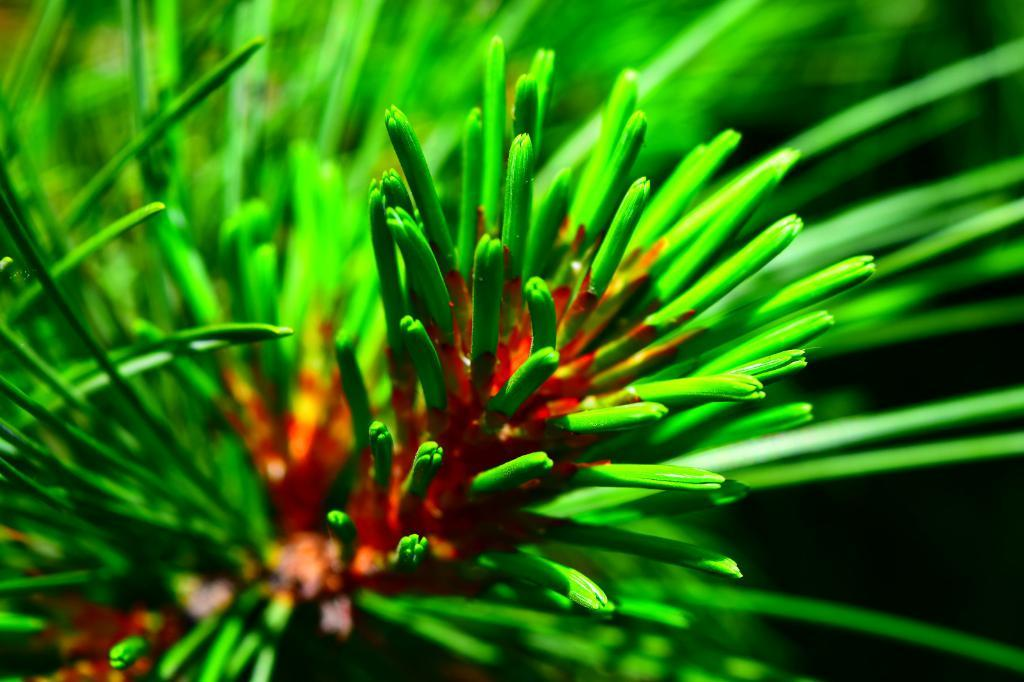What type of living organisms can be seen in the image? Plants can be seen in the image. Can you describe any specific features of the plants? There are red color flowers in the image. What type of toothpaste is being used to water the plants in the image? There is no toothpaste present in the image, and toothpaste is not used for watering plants. 